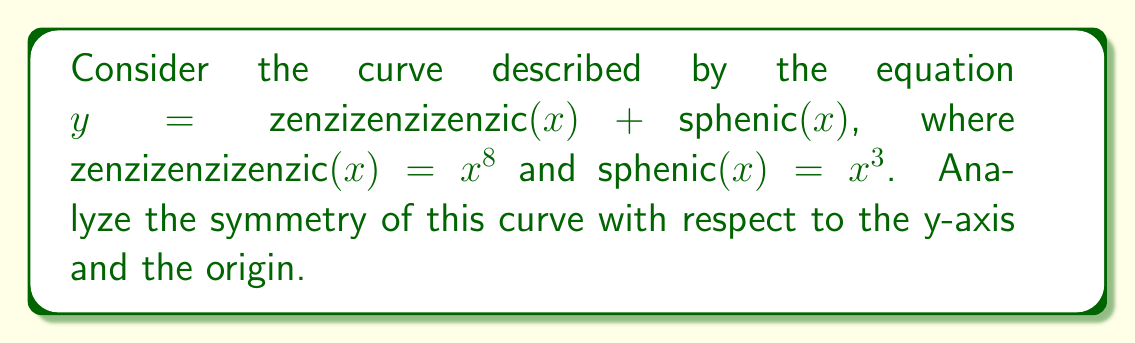Can you solve this math problem? To analyze the symmetry of the curve, we need to examine its behavior under reflection about the y-axis and rotation about the origin.

1. Symmetry about the y-axis:
   A curve is symmetric about the y-axis if $f(-x) = f(x)$ for all $x$.
   Let's substitute $-x$ for $x$ in our equation:
   
   $f(-x) = \text{zenzizenzizenzic}(-x) + \text{sphenic}(-x)$
   $= (-x)^8 + (-x)^3$
   $= x^8 - x^3$

   This is not equal to $f(x) = x^8 + x^3$ for all $x$, so the curve is not symmetric about the y-axis.

2. Symmetry about the origin:
   A curve is symmetric about the origin if $f(-x) = -f(x)$ for all $x$.
   We've already found $f(-x) = x^8 - x^3$.
   
   $-f(x) = -(x^8 + x^3) = -x^8 - x^3$

   Since $f(-x) \neq -f(x)$, the curve is not symmetric about the origin.

3. Odd and even components:
   We can split the function into its odd and even parts:
   
   Even part: $\frac{f(x) + f(-x)}{2} = \frac{(x^8 + x^3) + (x^8 - x^3)}{2} = x^8$
   Odd part: $\frac{f(x) - f(-x)}{2} = \frac{(x^8 + x^3) - (x^8 - x^3)}{2} = x^3$

   The presence of both odd and even components confirms the lack of overall symmetry.

In conclusion, the curve described by $y = \text{zenzizenzizenzic}(x) + \text{sphenic}(x)$ does not possess symmetry about the y-axis or the origin. It is composed of an even function (zenzizenzizenzic) and an odd function (sphenic), resulting in an asymmetric curve.
Answer: The curve $y = \text{zenzizenzizenzic}(x) + \text{sphenic}(x)$ is not symmetric about the y-axis or the origin. It is an asymmetric curve composed of an even component $(x^8)$ and an odd component $(x^3)$. 